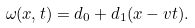<formula> <loc_0><loc_0><loc_500><loc_500>\omega ( x , t ) = d _ { 0 } + d _ { 1 } ( x - v t ) .</formula> 